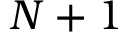Convert formula to latex. <formula><loc_0><loc_0><loc_500><loc_500>N + 1</formula> 